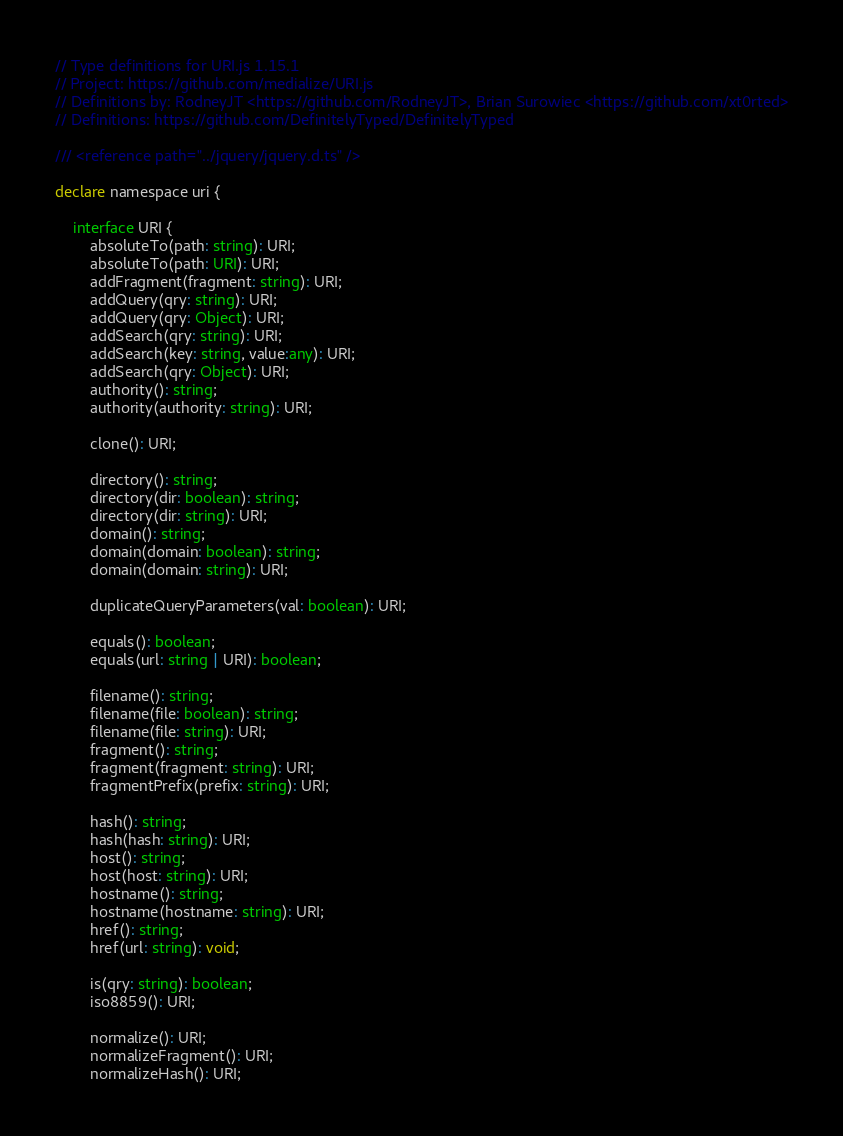Convert code to text. <code><loc_0><loc_0><loc_500><loc_500><_TypeScript_>// Type definitions for URI.js 1.15.1
// Project: https://github.com/medialize/URI.js
// Definitions by: RodneyJT <https://github.com/RodneyJT>, Brian Surowiec <https://github.com/xt0rted>
// Definitions: https://github.com/DefinitelyTyped/DefinitelyTyped

/// <reference path="../jquery/jquery.d.ts" />

declare namespace uri {

    interface URI {
        absoluteTo(path: string): URI;
        absoluteTo(path: URI): URI;
        addFragment(fragment: string): URI;
        addQuery(qry: string): URI;
        addQuery(qry: Object): URI;
        addSearch(qry: string): URI;
        addSearch(key: string, value:any): URI;
        addSearch(qry: Object): URI;
        authority(): string;
        authority(authority: string): URI;

        clone(): URI;

        directory(): string;
        directory(dir: boolean): string;
        directory(dir: string): URI;
        domain(): string;
        domain(domain: boolean): string;
        domain(domain: string): URI;

        duplicateQueryParameters(val: boolean): URI;

        equals(): boolean;
        equals(url: string | URI): boolean;

        filename(): string;
        filename(file: boolean): string;
        filename(file: string): URI;
        fragment(): string;
        fragment(fragment: string): URI;
        fragmentPrefix(prefix: string): URI;

        hash(): string;
        hash(hash: string): URI;
        host(): string;
        host(host: string): URI;
        hostname(): string;
        hostname(hostname: string): URI;
        href(): string;
        href(url: string): void;

        is(qry: string): boolean;
        iso8859(): URI;

        normalize(): URI;
        normalizeFragment(): URI;
        normalizeHash(): URI;</code> 